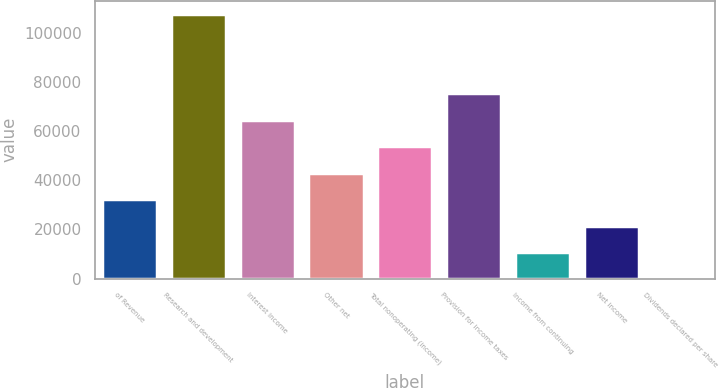Convert chart to OTSL. <chart><loc_0><loc_0><loc_500><loc_500><bar_chart><fcel>of Revenue<fcel>Research and development<fcel>Interest income<fcel>Other net<fcel>Total nonoperating (income)<fcel>Provision for income taxes<fcel>Income from continuing<fcel>Net income<fcel>Dividends declared per share<nl><fcel>32273.5<fcel>107578<fcel>64546.9<fcel>43031.3<fcel>53789.1<fcel>75304.7<fcel>10758<fcel>21515.8<fcel>0.2<nl></chart> 